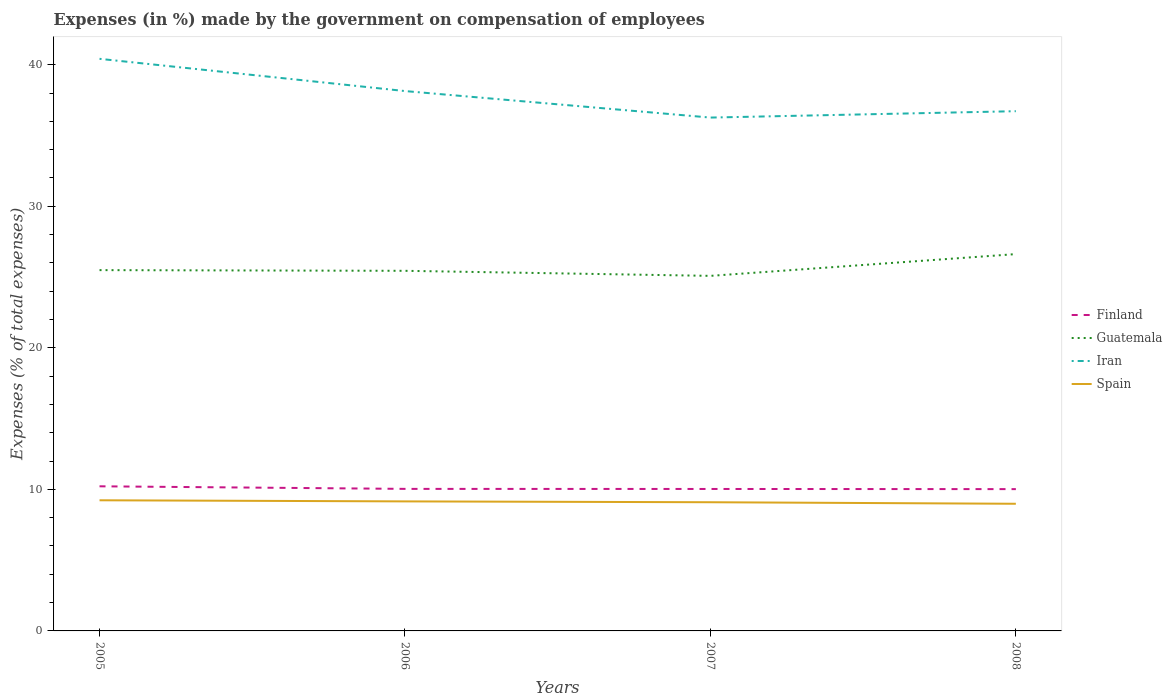How many different coloured lines are there?
Your answer should be very brief. 4. Across all years, what is the maximum percentage of expenses made by the government on compensation of employees in Finland?
Keep it short and to the point. 10.02. What is the total percentage of expenses made by the government on compensation of employees in Spain in the graph?
Offer a very short reply. 0.17. What is the difference between the highest and the second highest percentage of expenses made by the government on compensation of employees in Guatemala?
Your response must be concise. 1.54. What is the difference between the highest and the lowest percentage of expenses made by the government on compensation of employees in Finland?
Offer a terse response. 1. How many lines are there?
Your answer should be very brief. 4. Are the values on the major ticks of Y-axis written in scientific E-notation?
Provide a short and direct response. No. Where does the legend appear in the graph?
Your response must be concise. Center right. What is the title of the graph?
Your answer should be very brief. Expenses (in %) made by the government on compensation of employees. Does "Kenya" appear as one of the legend labels in the graph?
Your answer should be compact. No. What is the label or title of the X-axis?
Ensure brevity in your answer.  Years. What is the label or title of the Y-axis?
Ensure brevity in your answer.  Expenses (% of total expenses). What is the Expenses (% of total expenses) of Finland in 2005?
Keep it short and to the point. 10.22. What is the Expenses (% of total expenses) in Guatemala in 2005?
Your response must be concise. 25.49. What is the Expenses (% of total expenses) in Iran in 2005?
Offer a very short reply. 40.42. What is the Expenses (% of total expenses) in Spain in 2005?
Ensure brevity in your answer.  9.23. What is the Expenses (% of total expenses) in Finland in 2006?
Your answer should be very brief. 10.04. What is the Expenses (% of total expenses) of Guatemala in 2006?
Your response must be concise. 25.44. What is the Expenses (% of total expenses) of Iran in 2006?
Your answer should be compact. 38.14. What is the Expenses (% of total expenses) in Spain in 2006?
Ensure brevity in your answer.  9.15. What is the Expenses (% of total expenses) in Finland in 2007?
Your answer should be compact. 10.03. What is the Expenses (% of total expenses) in Guatemala in 2007?
Offer a terse response. 25.09. What is the Expenses (% of total expenses) in Iran in 2007?
Give a very brief answer. 36.27. What is the Expenses (% of total expenses) of Spain in 2007?
Offer a very short reply. 9.09. What is the Expenses (% of total expenses) in Finland in 2008?
Your response must be concise. 10.02. What is the Expenses (% of total expenses) in Guatemala in 2008?
Your response must be concise. 26.62. What is the Expenses (% of total expenses) in Iran in 2008?
Ensure brevity in your answer.  36.72. What is the Expenses (% of total expenses) of Spain in 2008?
Offer a very short reply. 8.98. Across all years, what is the maximum Expenses (% of total expenses) in Finland?
Your answer should be compact. 10.22. Across all years, what is the maximum Expenses (% of total expenses) in Guatemala?
Give a very brief answer. 26.62. Across all years, what is the maximum Expenses (% of total expenses) in Iran?
Your answer should be very brief. 40.42. Across all years, what is the maximum Expenses (% of total expenses) in Spain?
Keep it short and to the point. 9.23. Across all years, what is the minimum Expenses (% of total expenses) in Finland?
Ensure brevity in your answer.  10.02. Across all years, what is the minimum Expenses (% of total expenses) in Guatemala?
Keep it short and to the point. 25.09. Across all years, what is the minimum Expenses (% of total expenses) of Iran?
Make the answer very short. 36.27. Across all years, what is the minimum Expenses (% of total expenses) of Spain?
Ensure brevity in your answer.  8.98. What is the total Expenses (% of total expenses) in Finland in the graph?
Provide a short and direct response. 40.3. What is the total Expenses (% of total expenses) of Guatemala in the graph?
Give a very brief answer. 102.64. What is the total Expenses (% of total expenses) of Iran in the graph?
Make the answer very short. 151.55. What is the total Expenses (% of total expenses) of Spain in the graph?
Your answer should be compact. 36.46. What is the difference between the Expenses (% of total expenses) of Finland in 2005 and that in 2006?
Your answer should be compact. 0.18. What is the difference between the Expenses (% of total expenses) of Guatemala in 2005 and that in 2006?
Offer a terse response. 0.05. What is the difference between the Expenses (% of total expenses) of Iran in 2005 and that in 2006?
Ensure brevity in your answer.  2.28. What is the difference between the Expenses (% of total expenses) in Spain in 2005 and that in 2006?
Your answer should be very brief. 0.08. What is the difference between the Expenses (% of total expenses) in Finland in 2005 and that in 2007?
Make the answer very short. 0.19. What is the difference between the Expenses (% of total expenses) of Guatemala in 2005 and that in 2007?
Offer a terse response. 0.41. What is the difference between the Expenses (% of total expenses) of Iran in 2005 and that in 2007?
Offer a terse response. 4.15. What is the difference between the Expenses (% of total expenses) in Spain in 2005 and that in 2007?
Give a very brief answer. 0.14. What is the difference between the Expenses (% of total expenses) in Finland in 2005 and that in 2008?
Give a very brief answer. 0.2. What is the difference between the Expenses (% of total expenses) in Guatemala in 2005 and that in 2008?
Make the answer very short. -1.13. What is the difference between the Expenses (% of total expenses) of Iran in 2005 and that in 2008?
Your response must be concise. 3.7. What is the difference between the Expenses (% of total expenses) in Spain in 2005 and that in 2008?
Your answer should be very brief. 0.25. What is the difference between the Expenses (% of total expenses) of Finland in 2006 and that in 2007?
Provide a succinct answer. 0.01. What is the difference between the Expenses (% of total expenses) of Guatemala in 2006 and that in 2007?
Your answer should be very brief. 0.36. What is the difference between the Expenses (% of total expenses) in Iran in 2006 and that in 2007?
Provide a short and direct response. 1.87. What is the difference between the Expenses (% of total expenses) of Spain in 2006 and that in 2007?
Your response must be concise. 0.06. What is the difference between the Expenses (% of total expenses) of Finland in 2006 and that in 2008?
Offer a very short reply. 0.02. What is the difference between the Expenses (% of total expenses) of Guatemala in 2006 and that in 2008?
Make the answer very short. -1.18. What is the difference between the Expenses (% of total expenses) of Iran in 2006 and that in 2008?
Your response must be concise. 1.42. What is the difference between the Expenses (% of total expenses) of Spain in 2006 and that in 2008?
Keep it short and to the point. 0.17. What is the difference between the Expenses (% of total expenses) in Finland in 2007 and that in 2008?
Give a very brief answer. 0.01. What is the difference between the Expenses (% of total expenses) in Guatemala in 2007 and that in 2008?
Offer a terse response. -1.54. What is the difference between the Expenses (% of total expenses) in Iran in 2007 and that in 2008?
Ensure brevity in your answer.  -0.45. What is the difference between the Expenses (% of total expenses) of Spain in 2007 and that in 2008?
Ensure brevity in your answer.  0.11. What is the difference between the Expenses (% of total expenses) of Finland in 2005 and the Expenses (% of total expenses) of Guatemala in 2006?
Keep it short and to the point. -15.22. What is the difference between the Expenses (% of total expenses) in Finland in 2005 and the Expenses (% of total expenses) in Iran in 2006?
Provide a succinct answer. -27.92. What is the difference between the Expenses (% of total expenses) in Finland in 2005 and the Expenses (% of total expenses) in Spain in 2006?
Make the answer very short. 1.07. What is the difference between the Expenses (% of total expenses) of Guatemala in 2005 and the Expenses (% of total expenses) of Iran in 2006?
Your answer should be compact. -12.65. What is the difference between the Expenses (% of total expenses) in Guatemala in 2005 and the Expenses (% of total expenses) in Spain in 2006?
Keep it short and to the point. 16.34. What is the difference between the Expenses (% of total expenses) of Iran in 2005 and the Expenses (% of total expenses) of Spain in 2006?
Your answer should be very brief. 31.27. What is the difference between the Expenses (% of total expenses) in Finland in 2005 and the Expenses (% of total expenses) in Guatemala in 2007?
Offer a very short reply. -14.87. What is the difference between the Expenses (% of total expenses) in Finland in 2005 and the Expenses (% of total expenses) in Iran in 2007?
Ensure brevity in your answer.  -26.05. What is the difference between the Expenses (% of total expenses) in Finland in 2005 and the Expenses (% of total expenses) in Spain in 2007?
Offer a terse response. 1.13. What is the difference between the Expenses (% of total expenses) in Guatemala in 2005 and the Expenses (% of total expenses) in Iran in 2007?
Your answer should be compact. -10.78. What is the difference between the Expenses (% of total expenses) of Guatemala in 2005 and the Expenses (% of total expenses) of Spain in 2007?
Ensure brevity in your answer.  16.4. What is the difference between the Expenses (% of total expenses) of Iran in 2005 and the Expenses (% of total expenses) of Spain in 2007?
Give a very brief answer. 31.33. What is the difference between the Expenses (% of total expenses) of Finland in 2005 and the Expenses (% of total expenses) of Guatemala in 2008?
Your answer should be very brief. -16.41. What is the difference between the Expenses (% of total expenses) in Finland in 2005 and the Expenses (% of total expenses) in Iran in 2008?
Provide a short and direct response. -26.5. What is the difference between the Expenses (% of total expenses) of Finland in 2005 and the Expenses (% of total expenses) of Spain in 2008?
Your response must be concise. 1.23. What is the difference between the Expenses (% of total expenses) of Guatemala in 2005 and the Expenses (% of total expenses) of Iran in 2008?
Ensure brevity in your answer.  -11.23. What is the difference between the Expenses (% of total expenses) of Guatemala in 2005 and the Expenses (% of total expenses) of Spain in 2008?
Provide a short and direct response. 16.51. What is the difference between the Expenses (% of total expenses) in Iran in 2005 and the Expenses (% of total expenses) in Spain in 2008?
Ensure brevity in your answer.  31.44. What is the difference between the Expenses (% of total expenses) in Finland in 2006 and the Expenses (% of total expenses) in Guatemala in 2007?
Give a very brief answer. -15.05. What is the difference between the Expenses (% of total expenses) in Finland in 2006 and the Expenses (% of total expenses) in Iran in 2007?
Provide a short and direct response. -26.23. What is the difference between the Expenses (% of total expenses) in Finland in 2006 and the Expenses (% of total expenses) in Spain in 2007?
Make the answer very short. 0.94. What is the difference between the Expenses (% of total expenses) in Guatemala in 2006 and the Expenses (% of total expenses) in Iran in 2007?
Your answer should be compact. -10.83. What is the difference between the Expenses (% of total expenses) of Guatemala in 2006 and the Expenses (% of total expenses) of Spain in 2007?
Make the answer very short. 16.35. What is the difference between the Expenses (% of total expenses) in Iran in 2006 and the Expenses (% of total expenses) in Spain in 2007?
Keep it short and to the point. 29.05. What is the difference between the Expenses (% of total expenses) in Finland in 2006 and the Expenses (% of total expenses) in Guatemala in 2008?
Keep it short and to the point. -16.59. What is the difference between the Expenses (% of total expenses) of Finland in 2006 and the Expenses (% of total expenses) of Iran in 2008?
Your answer should be very brief. -26.68. What is the difference between the Expenses (% of total expenses) of Finland in 2006 and the Expenses (% of total expenses) of Spain in 2008?
Your answer should be very brief. 1.05. What is the difference between the Expenses (% of total expenses) of Guatemala in 2006 and the Expenses (% of total expenses) of Iran in 2008?
Make the answer very short. -11.28. What is the difference between the Expenses (% of total expenses) of Guatemala in 2006 and the Expenses (% of total expenses) of Spain in 2008?
Provide a short and direct response. 16.46. What is the difference between the Expenses (% of total expenses) of Iran in 2006 and the Expenses (% of total expenses) of Spain in 2008?
Keep it short and to the point. 29.16. What is the difference between the Expenses (% of total expenses) of Finland in 2007 and the Expenses (% of total expenses) of Guatemala in 2008?
Keep it short and to the point. -16.59. What is the difference between the Expenses (% of total expenses) in Finland in 2007 and the Expenses (% of total expenses) in Iran in 2008?
Provide a short and direct response. -26.69. What is the difference between the Expenses (% of total expenses) of Finland in 2007 and the Expenses (% of total expenses) of Spain in 2008?
Provide a succinct answer. 1.05. What is the difference between the Expenses (% of total expenses) in Guatemala in 2007 and the Expenses (% of total expenses) in Iran in 2008?
Keep it short and to the point. -11.63. What is the difference between the Expenses (% of total expenses) in Guatemala in 2007 and the Expenses (% of total expenses) in Spain in 2008?
Provide a short and direct response. 16.1. What is the difference between the Expenses (% of total expenses) of Iran in 2007 and the Expenses (% of total expenses) of Spain in 2008?
Give a very brief answer. 27.29. What is the average Expenses (% of total expenses) in Finland per year?
Offer a terse response. 10.08. What is the average Expenses (% of total expenses) in Guatemala per year?
Your response must be concise. 25.66. What is the average Expenses (% of total expenses) of Iran per year?
Offer a very short reply. 37.89. What is the average Expenses (% of total expenses) in Spain per year?
Provide a short and direct response. 9.11. In the year 2005, what is the difference between the Expenses (% of total expenses) of Finland and Expenses (% of total expenses) of Guatemala?
Your answer should be compact. -15.27. In the year 2005, what is the difference between the Expenses (% of total expenses) of Finland and Expenses (% of total expenses) of Iran?
Provide a short and direct response. -30.2. In the year 2005, what is the difference between the Expenses (% of total expenses) in Guatemala and Expenses (% of total expenses) in Iran?
Your answer should be compact. -14.93. In the year 2005, what is the difference between the Expenses (% of total expenses) of Guatemala and Expenses (% of total expenses) of Spain?
Offer a terse response. 16.26. In the year 2005, what is the difference between the Expenses (% of total expenses) of Iran and Expenses (% of total expenses) of Spain?
Your answer should be compact. 31.19. In the year 2006, what is the difference between the Expenses (% of total expenses) in Finland and Expenses (% of total expenses) in Guatemala?
Give a very brief answer. -15.41. In the year 2006, what is the difference between the Expenses (% of total expenses) in Finland and Expenses (% of total expenses) in Iran?
Ensure brevity in your answer.  -28.11. In the year 2006, what is the difference between the Expenses (% of total expenses) of Finland and Expenses (% of total expenses) of Spain?
Offer a very short reply. 0.88. In the year 2006, what is the difference between the Expenses (% of total expenses) of Guatemala and Expenses (% of total expenses) of Spain?
Keep it short and to the point. 16.29. In the year 2006, what is the difference between the Expenses (% of total expenses) in Iran and Expenses (% of total expenses) in Spain?
Offer a terse response. 28.99. In the year 2007, what is the difference between the Expenses (% of total expenses) in Finland and Expenses (% of total expenses) in Guatemala?
Make the answer very short. -15.06. In the year 2007, what is the difference between the Expenses (% of total expenses) in Finland and Expenses (% of total expenses) in Iran?
Offer a terse response. -26.24. In the year 2007, what is the difference between the Expenses (% of total expenses) of Finland and Expenses (% of total expenses) of Spain?
Give a very brief answer. 0.94. In the year 2007, what is the difference between the Expenses (% of total expenses) in Guatemala and Expenses (% of total expenses) in Iran?
Make the answer very short. -11.18. In the year 2007, what is the difference between the Expenses (% of total expenses) of Guatemala and Expenses (% of total expenses) of Spain?
Keep it short and to the point. 15.99. In the year 2007, what is the difference between the Expenses (% of total expenses) in Iran and Expenses (% of total expenses) in Spain?
Ensure brevity in your answer.  27.18. In the year 2008, what is the difference between the Expenses (% of total expenses) in Finland and Expenses (% of total expenses) in Guatemala?
Your response must be concise. -16.6. In the year 2008, what is the difference between the Expenses (% of total expenses) in Finland and Expenses (% of total expenses) in Iran?
Offer a very short reply. -26.7. In the year 2008, what is the difference between the Expenses (% of total expenses) in Finland and Expenses (% of total expenses) in Spain?
Give a very brief answer. 1.04. In the year 2008, what is the difference between the Expenses (% of total expenses) in Guatemala and Expenses (% of total expenses) in Iran?
Your response must be concise. -10.1. In the year 2008, what is the difference between the Expenses (% of total expenses) of Guatemala and Expenses (% of total expenses) of Spain?
Your answer should be very brief. 17.64. In the year 2008, what is the difference between the Expenses (% of total expenses) of Iran and Expenses (% of total expenses) of Spain?
Provide a succinct answer. 27.74. What is the ratio of the Expenses (% of total expenses) in Finland in 2005 to that in 2006?
Provide a short and direct response. 1.02. What is the ratio of the Expenses (% of total expenses) in Iran in 2005 to that in 2006?
Provide a short and direct response. 1.06. What is the ratio of the Expenses (% of total expenses) of Spain in 2005 to that in 2006?
Provide a succinct answer. 1.01. What is the ratio of the Expenses (% of total expenses) of Finland in 2005 to that in 2007?
Ensure brevity in your answer.  1.02. What is the ratio of the Expenses (% of total expenses) in Guatemala in 2005 to that in 2007?
Offer a terse response. 1.02. What is the ratio of the Expenses (% of total expenses) of Iran in 2005 to that in 2007?
Provide a short and direct response. 1.11. What is the ratio of the Expenses (% of total expenses) of Spain in 2005 to that in 2007?
Ensure brevity in your answer.  1.02. What is the ratio of the Expenses (% of total expenses) in Finland in 2005 to that in 2008?
Offer a very short reply. 1.02. What is the ratio of the Expenses (% of total expenses) of Guatemala in 2005 to that in 2008?
Provide a succinct answer. 0.96. What is the ratio of the Expenses (% of total expenses) of Iran in 2005 to that in 2008?
Provide a succinct answer. 1.1. What is the ratio of the Expenses (% of total expenses) of Spain in 2005 to that in 2008?
Offer a very short reply. 1.03. What is the ratio of the Expenses (% of total expenses) in Guatemala in 2006 to that in 2007?
Your answer should be very brief. 1.01. What is the ratio of the Expenses (% of total expenses) of Iran in 2006 to that in 2007?
Your answer should be very brief. 1.05. What is the ratio of the Expenses (% of total expenses) of Finland in 2006 to that in 2008?
Offer a very short reply. 1. What is the ratio of the Expenses (% of total expenses) of Guatemala in 2006 to that in 2008?
Make the answer very short. 0.96. What is the ratio of the Expenses (% of total expenses) in Iran in 2006 to that in 2008?
Make the answer very short. 1.04. What is the ratio of the Expenses (% of total expenses) of Spain in 2006 to that in 2008?
Your answer should be very brief. 1.02. What is the ratio of the Expenses (% of total expenses) of Finland in 2007 to that in 2008?
Your answer should be compact. 1. What is the ratio of the Expenses (% of total expenses) of Guatemala in 2007 to that in 2008?
Your answer should be compact. 0.94. What is the ratio of the Expenses (% of total expenses) of Iran in 2007 to that in 2008?
Your answer should be very brief. 0.99. What is the ratio of the Expenses (% of total expenses) in Spain in 2007 to that in 2008?
Ensure brevity in your answer.  1.01. What is the difference between the highest and the second highest Expenses (% of total expenses) of Finland?
Your answer should be very brief. 0.18. What is the difference between the highest and the second highest Expenses (% of total expenses) in Guatemala?
Ensure brevity in your answer.  1.13. What is the difference between the highest and the second highest Expenses (% of total expenses) of Iran?
Offer a very short reply. 2.28. What is the difference between the highest and the second highest Expenses (% of total expenses) in Spain?
Provide a short and direct response. 0.08. What is the difference between the highest and the lowest Expenses (% of total expenses) of Finland?
Ensure brevity in your answer.  0.2. What is the difference between the highest and the lowest Expenses (% of total expenses) in Guatemala?
Ensure brevity in your answer.  1.54. What is the difference between the highest and the lowest Expenses (% of total expenses) of Iran?
Give a very brief answer. 4.15. What is the difference between the highest and the lowest Expenses (% of total expenses) of Spain?
Your answer should be very brief. 0.25. 